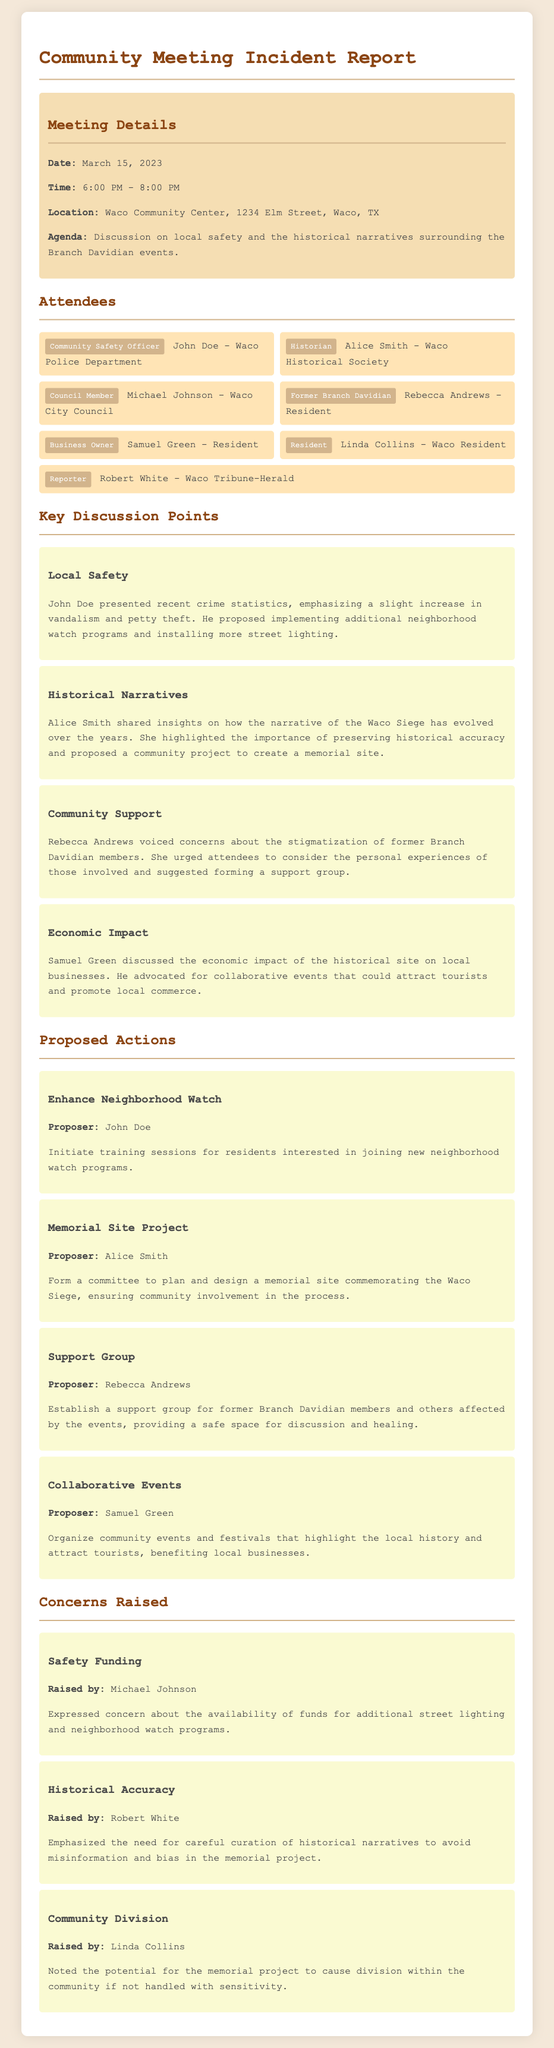What was the date of the meeting? The specific date of the community meeting is mentioned in the meeting details section.
Answer: March 15, 2023 Who proposed the establishment of a support group? The document specifies the individuals who proposed various actions, including the support group, in the proposed actions section.
Answer: Rebecca Andrews What location hosted the community meeting? The meeting details section provides the address where the meeting took place.
Answer: Waco Community Center, 1234 Elm Street, Waco, TX What concern did Michael Johnson raise? The concerns section lists the issues raised by different attendees, including Michael Johnson's concern about safety funding.
Answer: Safety Funding How many attendees are listed in the report? The report includes a specific list of attendees under the attendees section, which can be counted.
Answer: 7 What is one proposed action to enhance local safety? The proposed actions section outlines various initiatives, including one focused on neighborhood watch programs.
Answer: Enhance Neighborhood Watch Which former Branch Davidian member attended the meeting? The document contains the names and titles of attendees, including former members of Branch Davidian.
Answer: Rebecca Andrews What did Alice Smith propose? The proposed actions section includes Alice Smith's proposal related to preserving historical narratives, indicating her suggestion for a specific project.
Answer: Memorial Site Project 